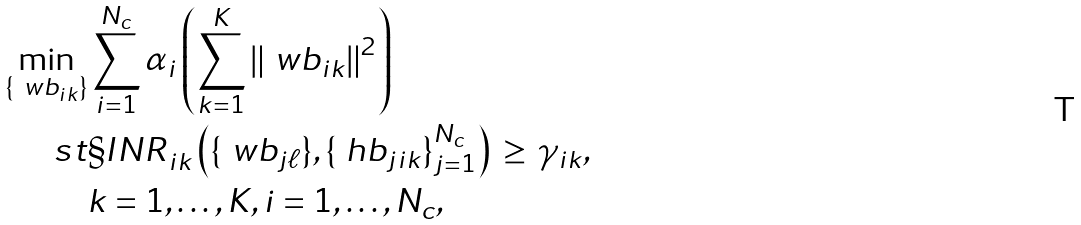Convert formula to latex. <formula><loc_0><loc_0><loc_500><loc_500>\min _ { \{ \ w b _ { i k } \} } & \sum _ { i = 1 } ^ { N _ { c } } { \alpha _ { i } } \left ( { \sum _ { k = 1 } ^ { K } { \left \| \ w b _ { i k } \right \| ^ { 2 } } } \right ) \\ \ s t & { { \S I N R } _ { i k } } \left ( \{ \ w b _ { j \ell } \} , \{ \ h b _ { j i k } \} _ { j = 1 } ^ { N _ { c } } \right ) \, \geq \, \gamma _ { i k } , \\ & k = 1 , \dots , K , i = 1 , \dots , N _ { c } ,</formula> 